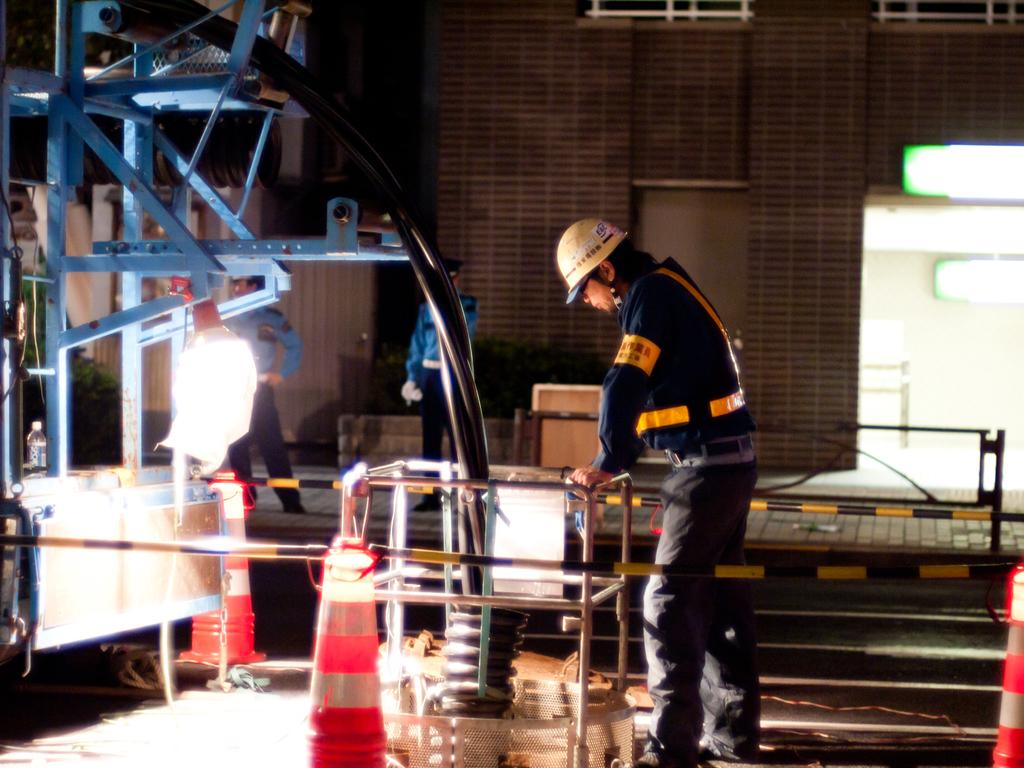How many people can be seen in the image? There are people in the image, but the exact number is not specified. What is one person holding in the image? One person is holding a rod in the image. What safety equipment is present in the image? Traffic cones are present in the image. What type of materials can be seen in the image? Iron materials are present in the image. What type of light source is visible in the image? Lights are visible in the image. What type of man-made structure is present in the image? There is a building in the image. What objects are present in the image? There are objects in the image, but their specific nature is not mentioned. What architectural features are visible in the image? The windows are visible in the image. What type of lettuce is growing on the building in the image? There is no lettuce growing on the building in the image. What type of appliance is being used by the people in the image? The provided facts do not mention any appliances being used by the people in the image. 